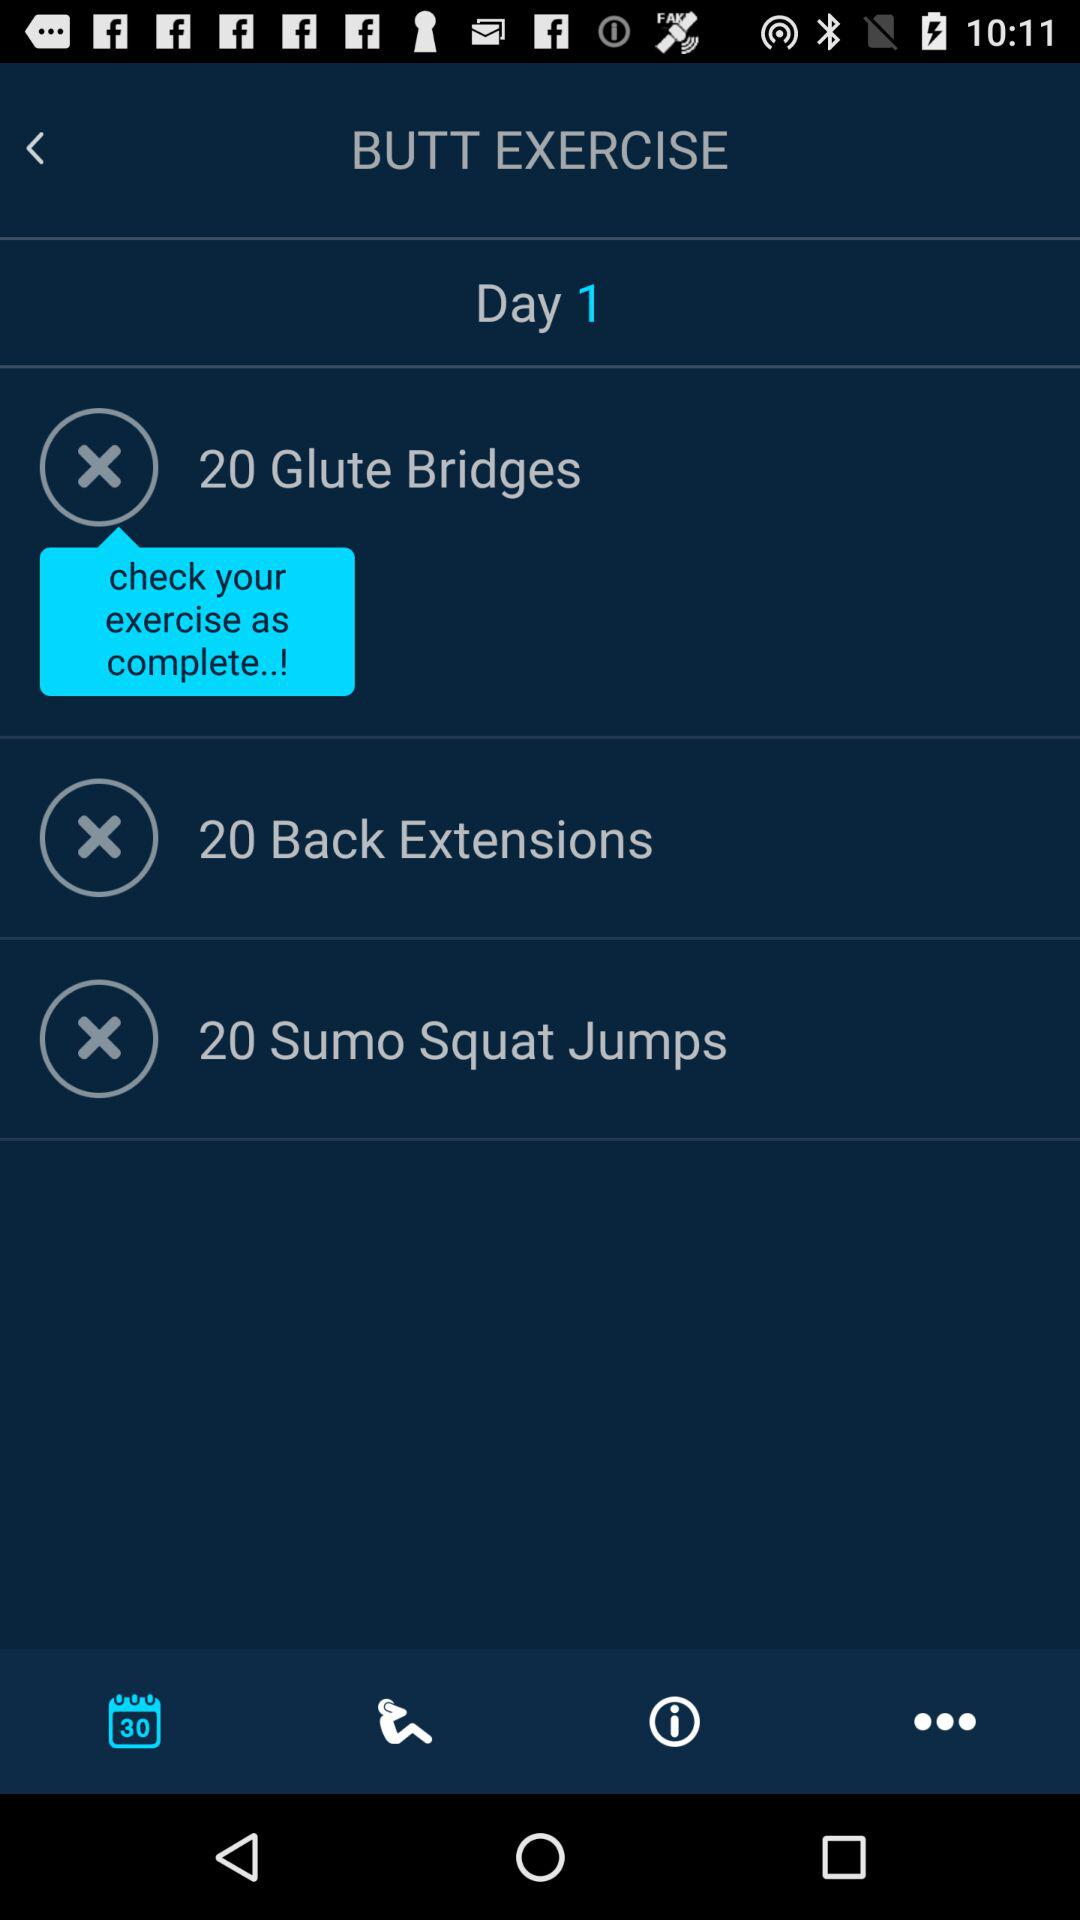How many exercises have been completed?
Answer the question using a single word or phrase. 0 